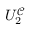Convert formula to latex. <formula><loc_0><loc_0><loc_500><loc_500>U _ { 2 } ^ { \mathcal { C } }</formula> 